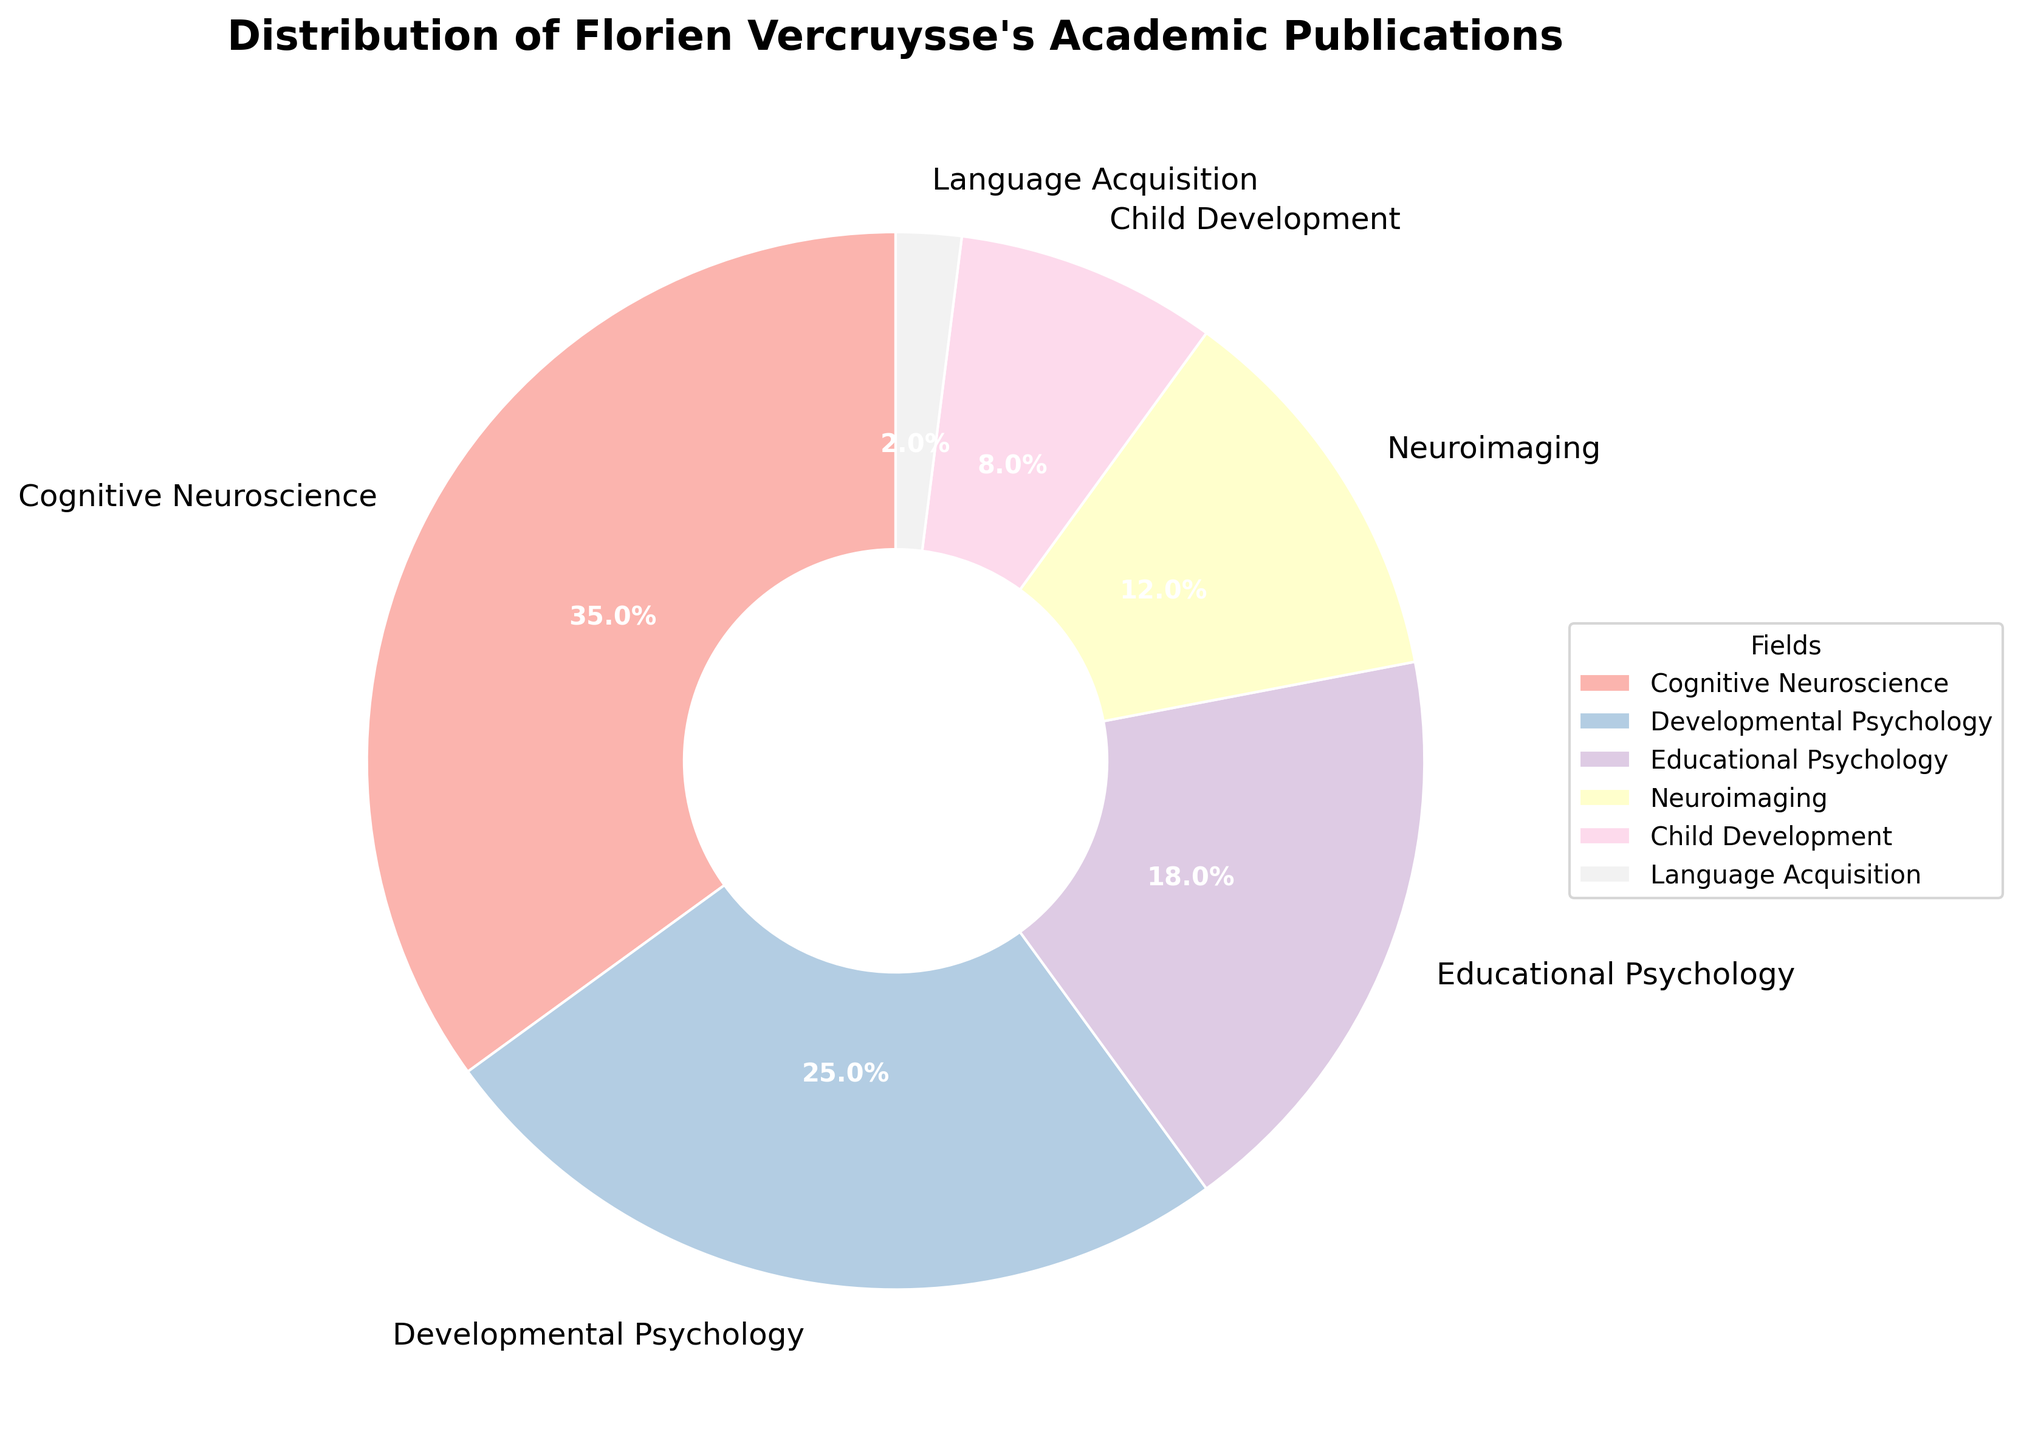What percentage of Florien Vercruysse's academic publications were in Cognitive Neuroscience? By referring to the figure, we see that the section labeled "Cognitive Neuroscience" represents 35% of the total publications.
Answer: 35% Which field has the smallest proportion of publications? By looking at the segments of the pie chart, the smallest one is labeled "Language Acquisition," which has a proportion of 2%.
Answer: Language Acquisition How much more percentage is contributed by Cognitive Neuroscience compared to Child Development? From the figure, Cognitive Neuroscience accounts for 35% and Child Development accounts for 8%. Subtract 8% from 35% to get the difference: 35% - 8% = 27%.
Answer: 27% If we combine the percentages of Educational Psychology and Developmental Psychology, what is the total percentage? Educational Psychology contributes 18%, and Developmental Psychology contributes 25%. Their combined percentage is 18% + 25% = 43%.
Answer: 43% How does the percentage of publications in Neuroimaging compare to that in Child Development? From the chart, Neuroimaging accounts for 12% and Child Development 8%. Therefore, Neuroimaging has a higher percentage by 4% (12% - 8% = 4%).
Answer: 4% What is the ratio of Cognitive Neuroscience publications to Neuroimaging publications? Cognitive Neuroscience represents 35% and Neuroimaging represents 12%. The ratio is therefore 35:12, which can be simplified to 35/12 or approximately 2.92.
Answer: 2.92 What is the cumulative percentage of publications in Cognitive Neuroscience, Developmental Psychology, and Educational Psychology? The percentages are 35%, 25%, and 18% respectively. Adding them gives: 35% + 25% + 18% = 78%.
Answer: 78% Compare the total percentage of publications in fields related to Psychology (Developmental Psychology + Educational Psychology) with those related to Neuroscience (Cognitive Neuroscience + Neuroimaging). Developmental Psychology and Educational Psychology contribute 25% and 18%, respectively, for a total of 43%. Cognitive Neuroscience and Neuroimaging contribute 35% and 12%, respectively, for a total of 47%.
Answer: 4% How does the size of the wedge corresponding to Educational Psychology visually compare to that of Developmental Psychology? By visually comparing the pie chart wedges, the one labeled "Developmental Psychology" is slightly larger than the wedge for "Educational Psychology". Educational Psychology has 18%, while Developmental Psychology has 25%.
Answer: Developmental Psychology larger 